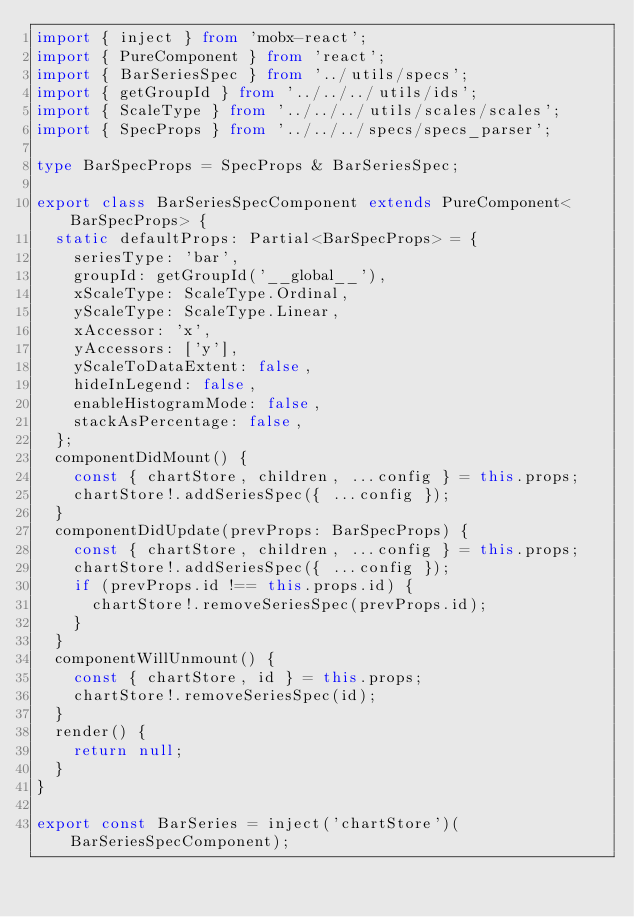Convert code to text. <code><loc_0><loc_0><loc_500><loc_500><_TypeScript_>import { inject } from 'mobx-react';
import { PureComponent } from 'react';
import { BarSeriesSpec } from '../utils/specs';
import { getGroupId } from '../../../utils/ids';
import { ScaleType } from '../../../utils/scales/scales';
import { SpecProps } from '../../../specs/specs_parser';

type BarSpecProps = SpecProps & BarSeriesSpec;

export class BarSeriesSpecComponent extends PureComponent<BarSpecProps> {
  static defaultProps: Partial<BarSpecProps> = {
    seriesType: 'bar',
    groupId: getGroupId('__global__'),
    xScaleType: ScaleType.Ordinal,
    yScaleType: ScaleType.Linear,
    xAccessor: 'x',
    yAccessors: ['y'],
    yScaleToDataExtent: false,
    hideInLegend: false,
    enableHistogramMode: false,
    stackAsPercentage: false,
  };
  componentDidMount() {
    const { chartStore, children, ...config } = this.props;
    chartStore!.addSeriesSpec({ ...config });
  }
  componentDidUpdate(prevProps: BarSpecProps) {
    const { chartStore, children, ...config } = this.props;
    chartStore!.addSeriesSpec({ ...config });
    if (prevProps.id !== this.props.id) {
      chartStore!.removeSeriesSpec(prevProps.id);
    }
  }
  componentWillUnmount() {
    const { chartStore, id } = this.props;
    chartStore!.removeSeriesSpec(id);
  }
  render() {
    return null;
  }
}

export const BarSeries = inject('chartStore')(BarSeriesSpecComponent);
</code> 